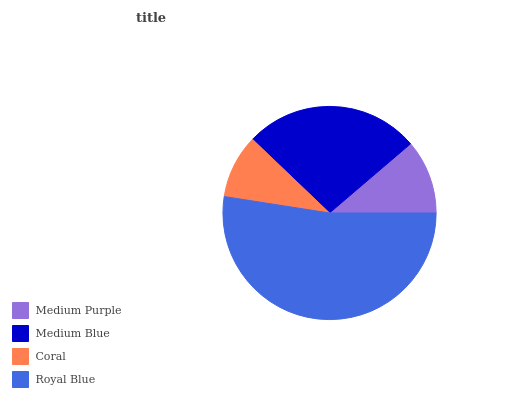Is Coral the minimum?
Answer yes or no. Yes. Is Royal Blue the maximum?
Answer yes or no. Yes. Is Medium Blue the minimum?
Answer yes or no. No. Is Medium Blue the maximum?
Answer yes or no. No. Is Medium Blue greater than Medium Purple?
Answer yes or no. Yes. Is Medium Purple less than Medium Blue?
Answer yes or no. Yes. Is Medium Purple greater than Medium Blue?
Answer yes or no. No. Is Medium Blue less than Medium Purple?
Answer yes or no. No. Is Medium Blue the high median?
Answer yes or no. Yes. Is Medium Purple the low median?
Answer yes or no. Yes. Is Royal Blue the high median?
Answer yes or no. No. Is Medium Blue the low median?
Answer yes or no. No. 